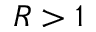Convert formula to latex. <formula><loc_0><loc_0><loc_500><loc_500>R > 1</formula> 